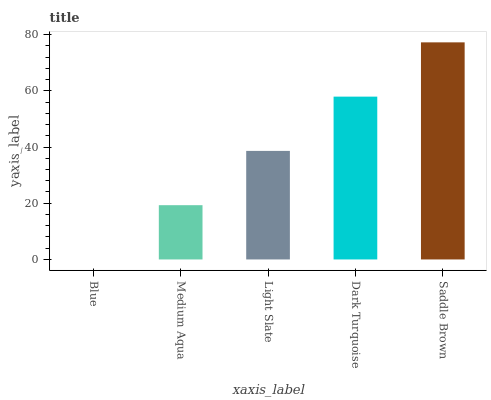Is Blue the minimum?
Answer yes or no. Yes. Is Saddle Brown the maximum?
Answer yes or no. Yes. Is Medium Aqua the minimum?
Answer yes or no. No. Is Medium Aqua the maximum?
Answer yes or no. No. Is Medium Aqua greater than Blue?
Answer yes or no. Yes. Is Blue less than Medium Aqua?
Answer yes or no. Yes. Is Blue greater than Medium Aqua?
Answer yes or no. No. Is Medium Aqua less than Blue?
Answer yes or no. No. Is Light Slate the high median?
Answer yes or no. Yes. Is Light Slate the low median?
Answer yes or no. Yes. Is Saddle Brown the high median?
Answer yes or no. No. Is Medium Aqua the low median?
Answer yes or no. No. 